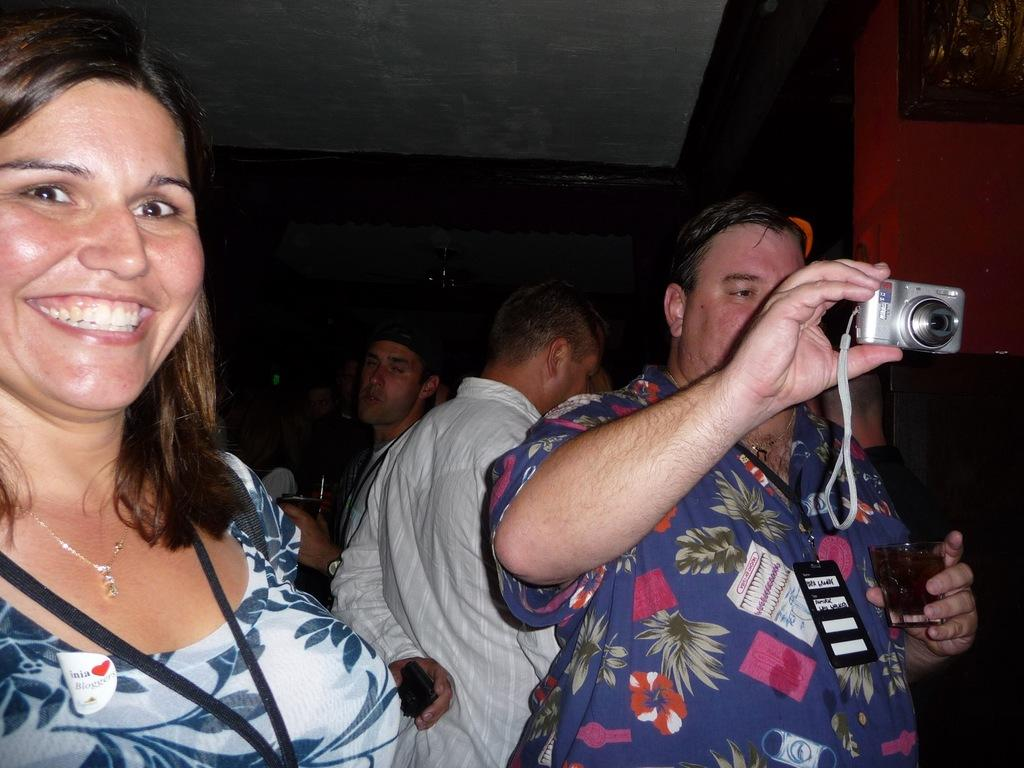What is the main subject of the image? The main subject of the image is people standing. Can you describe what one of the people is holding? Yes, there is a man holding a camera in his hand. What type of scent can be smelled coming from the hole in the image? There is no hole present in the image, so it's not possible to determine what, if any, scent might be smelled. 